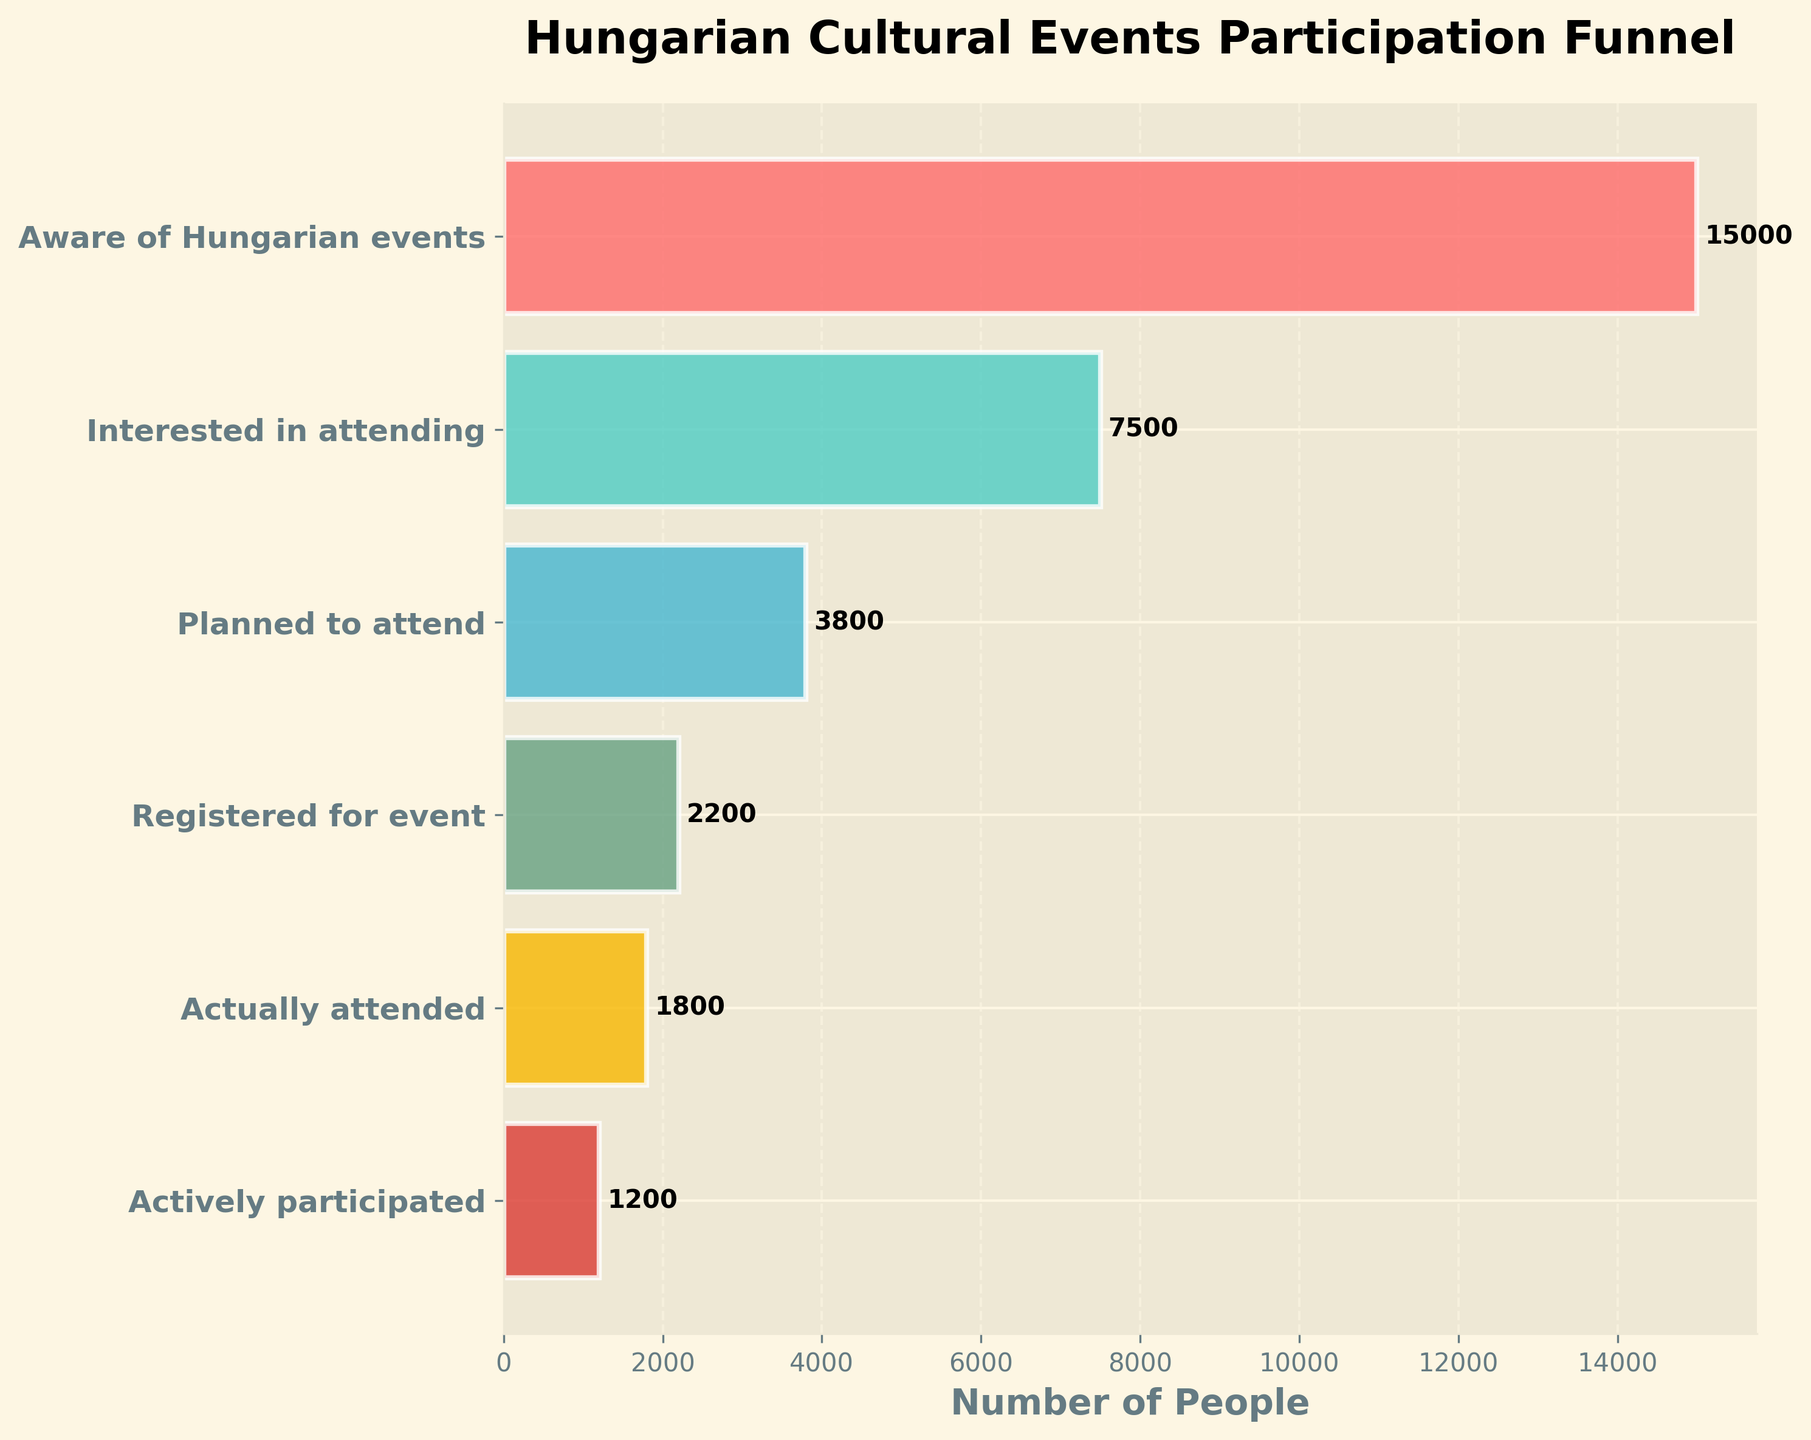What is the total number of people aware of Hungarian events? The figure indicates the number of people at each stage of the funnel, with the first stage labeled 'Aware of Hungarian events'.
Answer: 15000 How many people are actually attending events compared to those registered? The number of people who registered is given as 2200, while those who actually attended is 1800.
Answer: 1800 How many more people are aware of Hungarian events than actively participate? Subtract the number of people in the 'Actively participated' stage (1200) from those who are 'Aware of Hungarian events' (15000).
Answer: 13800 Compare the number of people interested in attending and those who actually attended. The numbers are given directly in the figure: 7500 are interested, and 1800 actually attended.
Answer: 7500 and 1800 What percentage of people who planned to attend actually attended? The number of people who planned to attend is 3800 and those who actually attended are 1800. To find the percentage, divide 1800 by 3800 and multiply by 100.
Answer: Approximately 47.37% At which stage do we see the largest drop in the number of participants? The figure shows the number of people at each stage, indicating the drop in participation. The largest drop is from 'Interested in attending' (7500) to 'Planned to attend' (3800).
Answer: From interested to planned Which stage has the smallest number of participants? The figure lists the stages and shows that 'Actively participated' has the smallest number.
Answer: Actively participated What is the title of the funnel chart? The title appears at the top of the chart.
Answer: Hungarian Cultural Events Participation Funnel How many stages are there in the funnel chart? The chart depicts the stages from awareness to active participation, and counting them will give the total number.
Answer: 6 stages Compare the number of people registered for the event to those who are aware of the events. The figure gives the number of people who registered (2200) and those aware (15000).
Answer: 2200 and 15000 